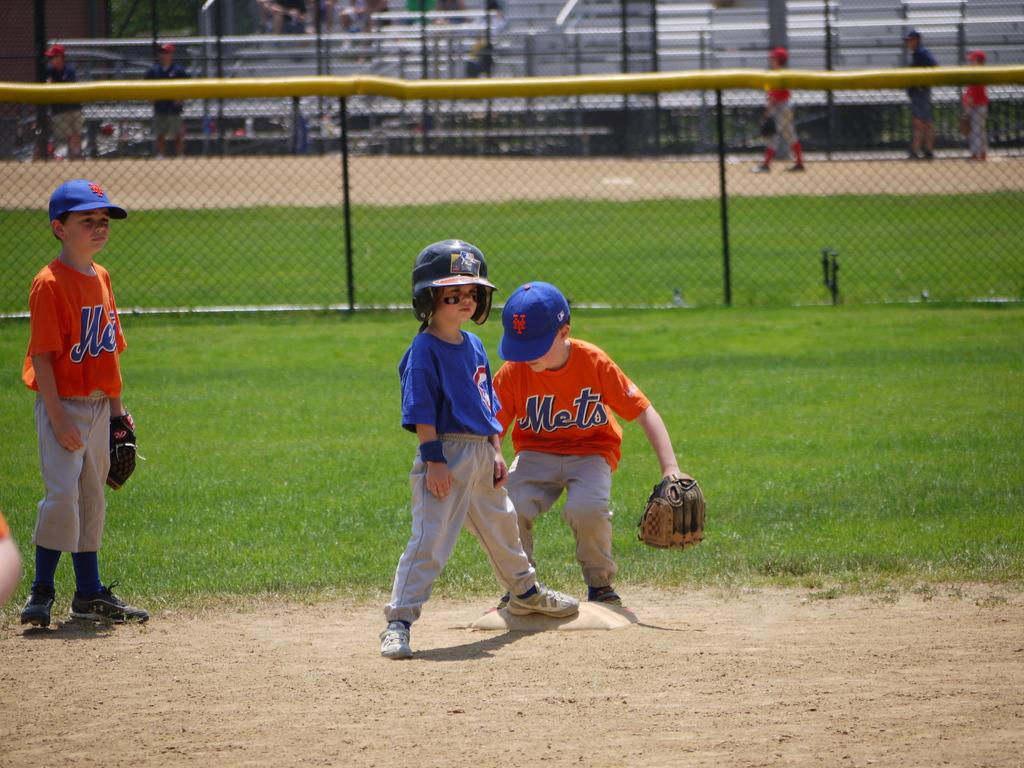<image>
Describe the image concisely. a little kid with a Mets jersey on a field 